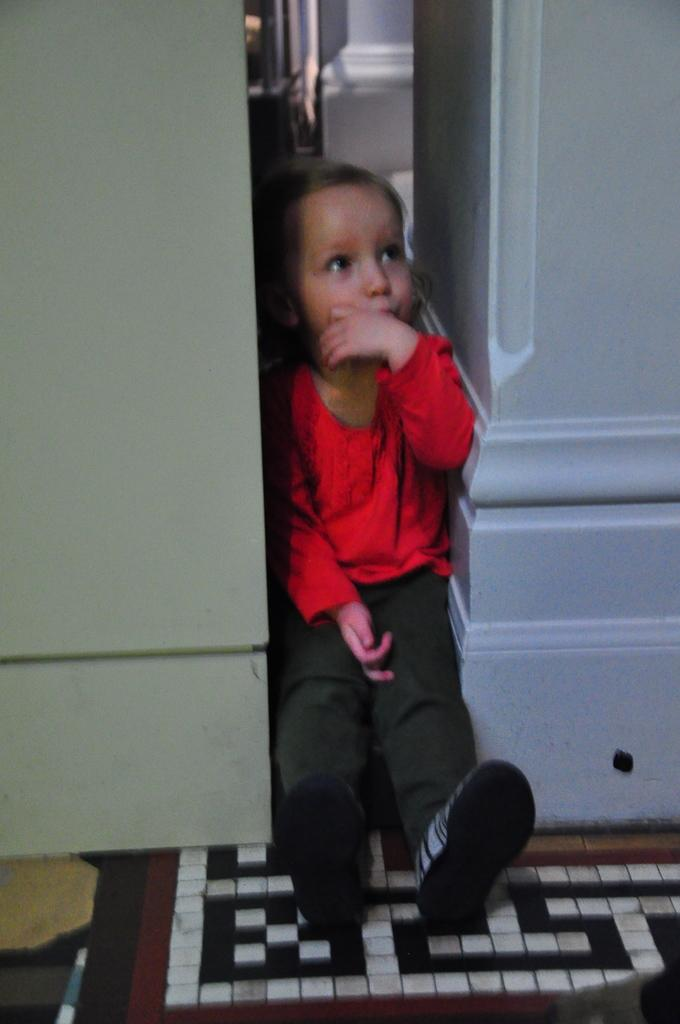What is the main subject of the image? There is a child in the image. What is the child wearing? The child is wearing a red dress and shoes. Where is the child sitting in the image? The child is sitting between a wall and an object. What can be seen on the floor in the image? There is a doormat on the floor in the image. How does the child's digestion process appear in the image? The image does not show the child's digestion process; it only shows the child sitting between a wall and an object, wearing a red dress and shoes, and sitting near a doormat. 